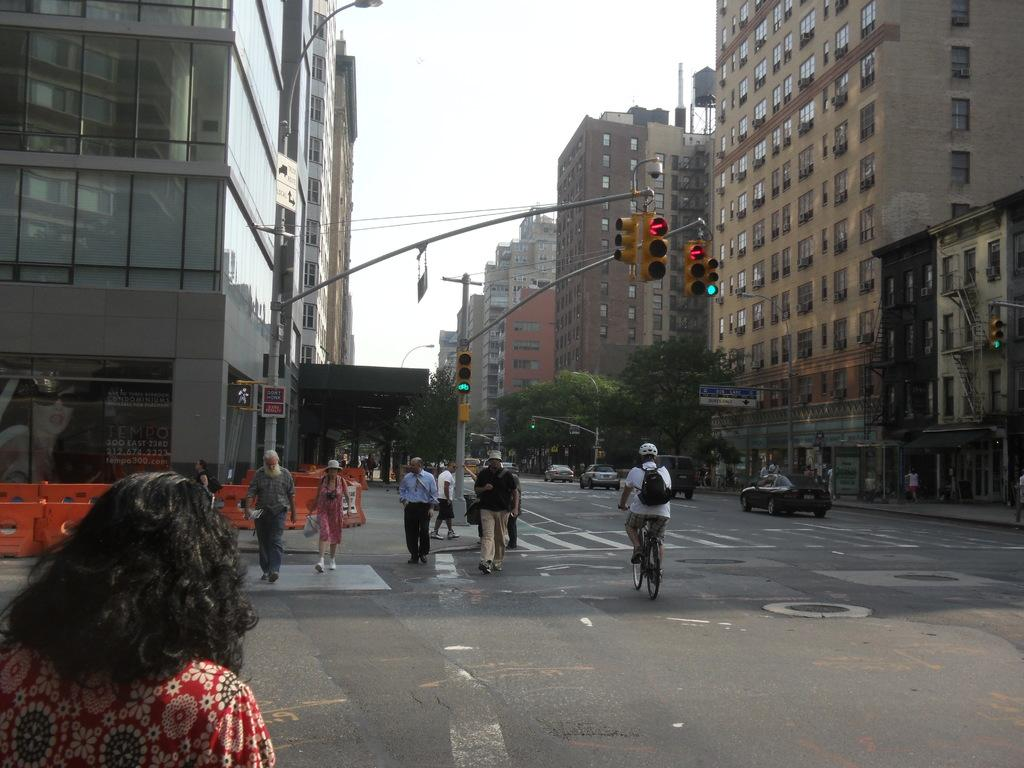How many persons are visible in the image? There are persons in the image, but the exact number is not specified. What can be seen on the road in the image? There are vehicles on the road in the image. What is visible in the background of the image? Buildings, trees, traffic signals, and the sky are visible in the background of the image. What type of disease is affecting the sheep in the image? There are no sheep present in the image, so it is not possible to determine if any disease is affecting them. How is the hose being used in the image? There is no hose present in the image, so it is not possible to describe its use. 